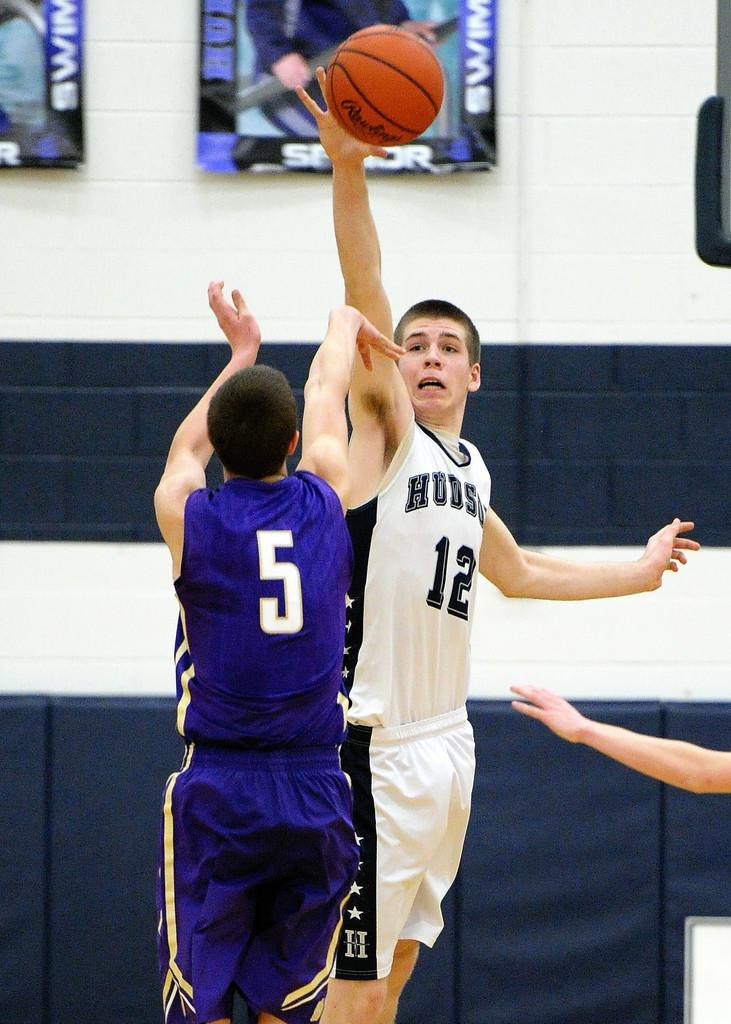<image>
Give a short and clear explanation of the subsequent image. Player number 5 and player number 12 tip off in a clash for the ball. 